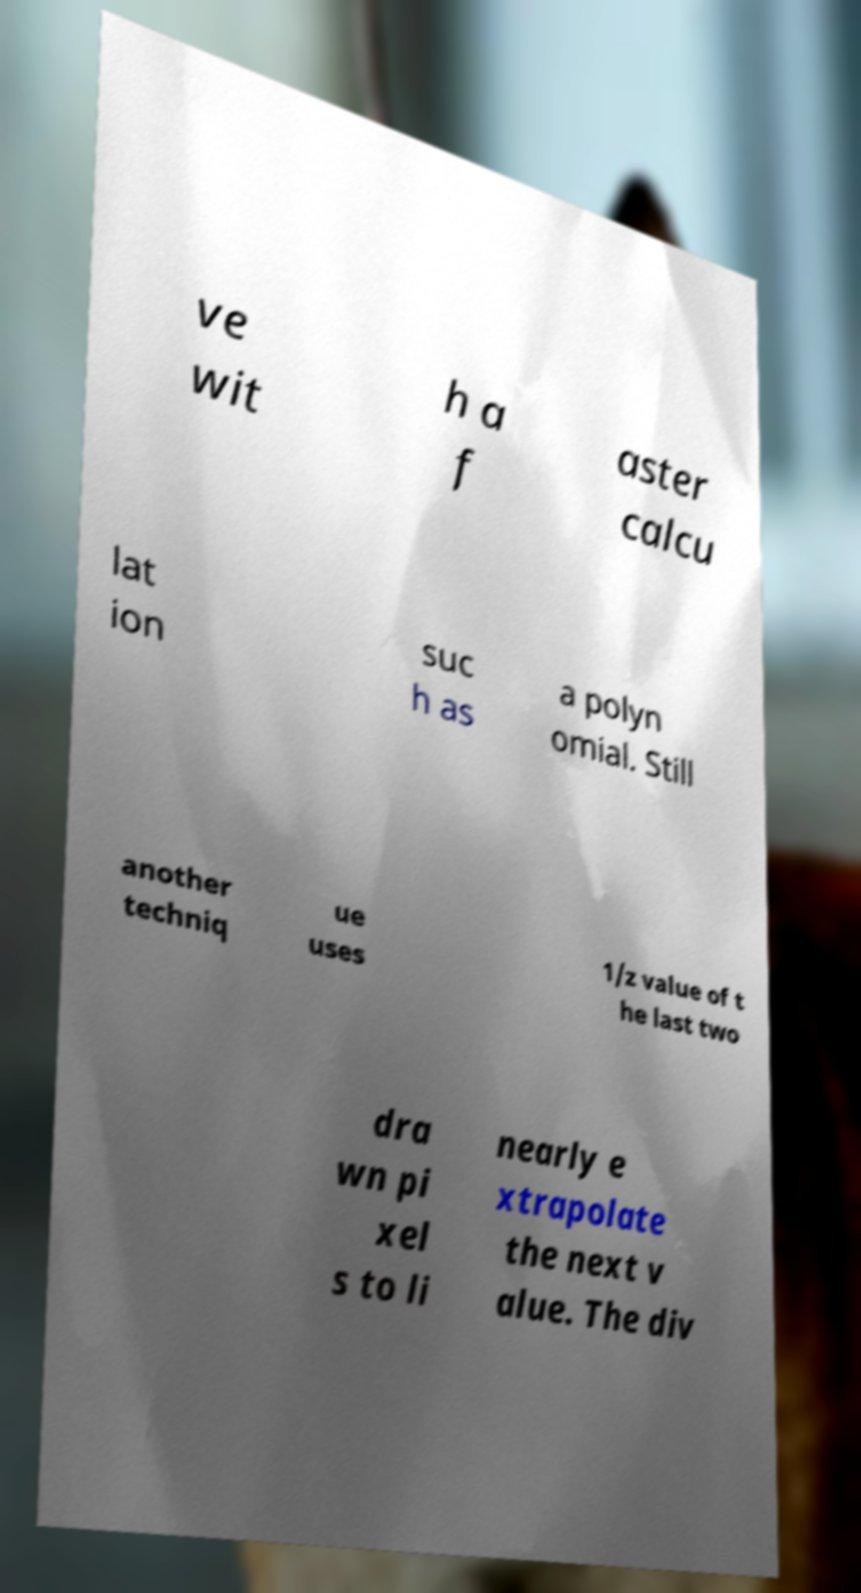There's text embedded in this image that I need extracted. Can you transcribe it verbatim? ve wit h a f aster calcu lat ion suc h as a polyn omial. Still another techniq ue uses 1/z value of t he last two dra wn pi xel s to li nearly e xtrapolate the next v alue. The div 